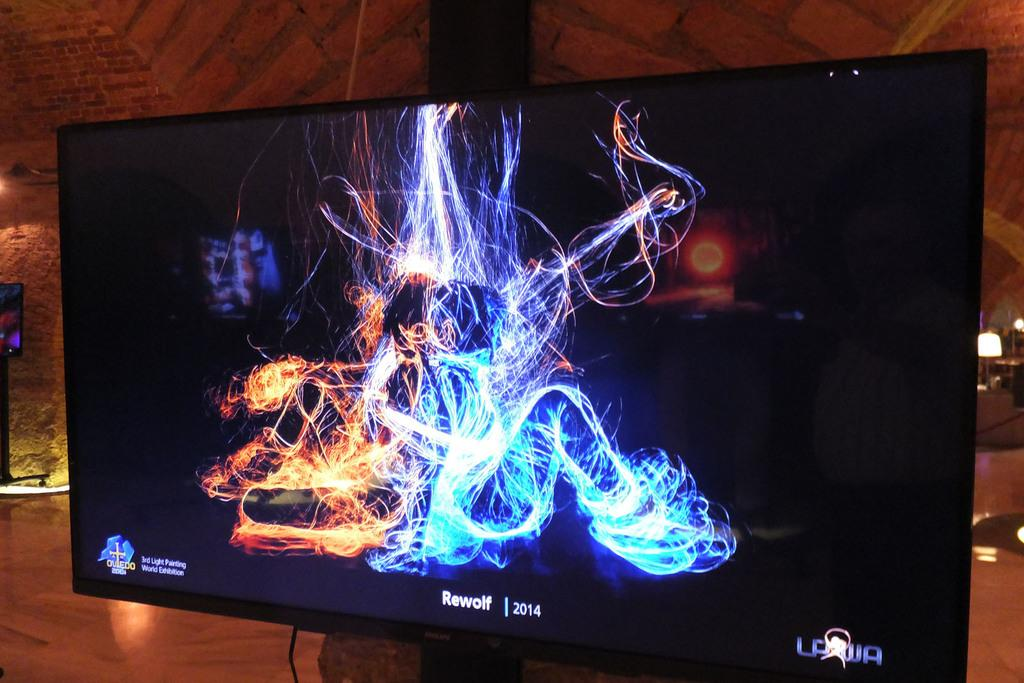<image>
Write a terse but informative summary of the picture. A TV screen with red and blue lines and says Rewolf 